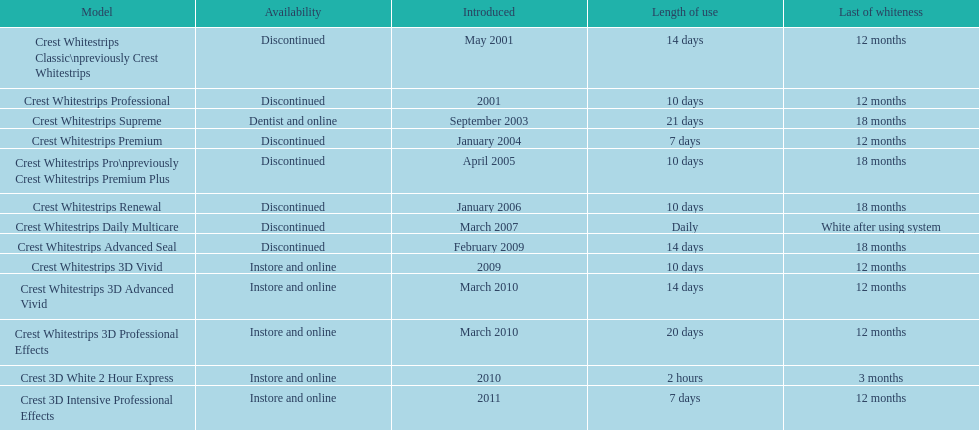How many models require less than a week of use? 2. 